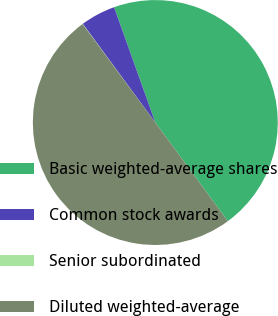<chart> <loc_0><loc_0><loc_500><loc_500><pie_chart><fcel>Basic weighted-average shares<fcel>Common stock awards<fcel>Senior subordinated<fcel>Diluted weighted-average<nl><fcel>45.38%<fcel>4.62%<fcel>0.04%<fcel>49.96%<nl></chart> 